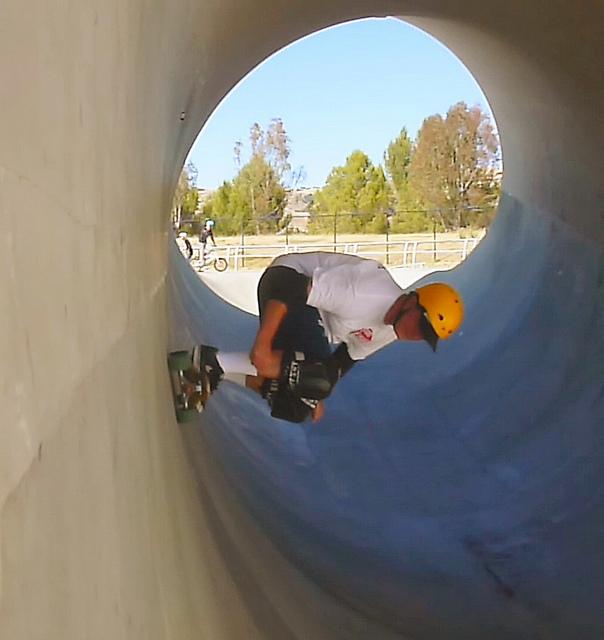Is there any children playing in the background?
Keep it brief. Yes. Where is the boy at?
Give a very brief answer. Tunnel. Is the man wearing protective headgear?
Quick response, please. Yes. 